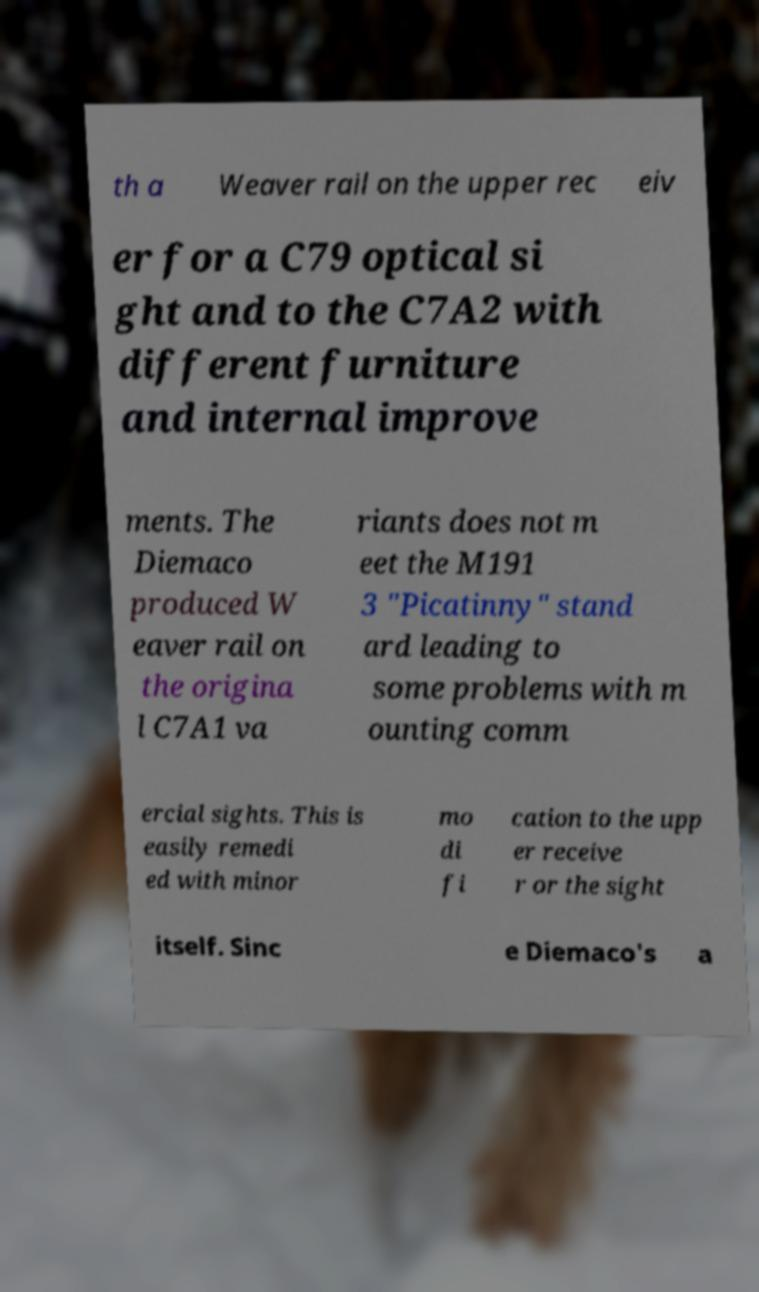What messages or text are displayed in this image? I need them in a readable, typed format. th a Weaver rail on the upper rec eiv er for a C79 optical si ght and to the C7A2 with different furniture and internal improve ments. The Diemaco produced W eaver rail on the origina l C7A1 va riants does not m eet the M191 3 "Picatinny" stand ard leading to some problems with m ounting comm ercial sights. This is easily remedi ed with minor mo di fi cation to the upp er receive r or the sight itself. Sinc e Diemaco's a 